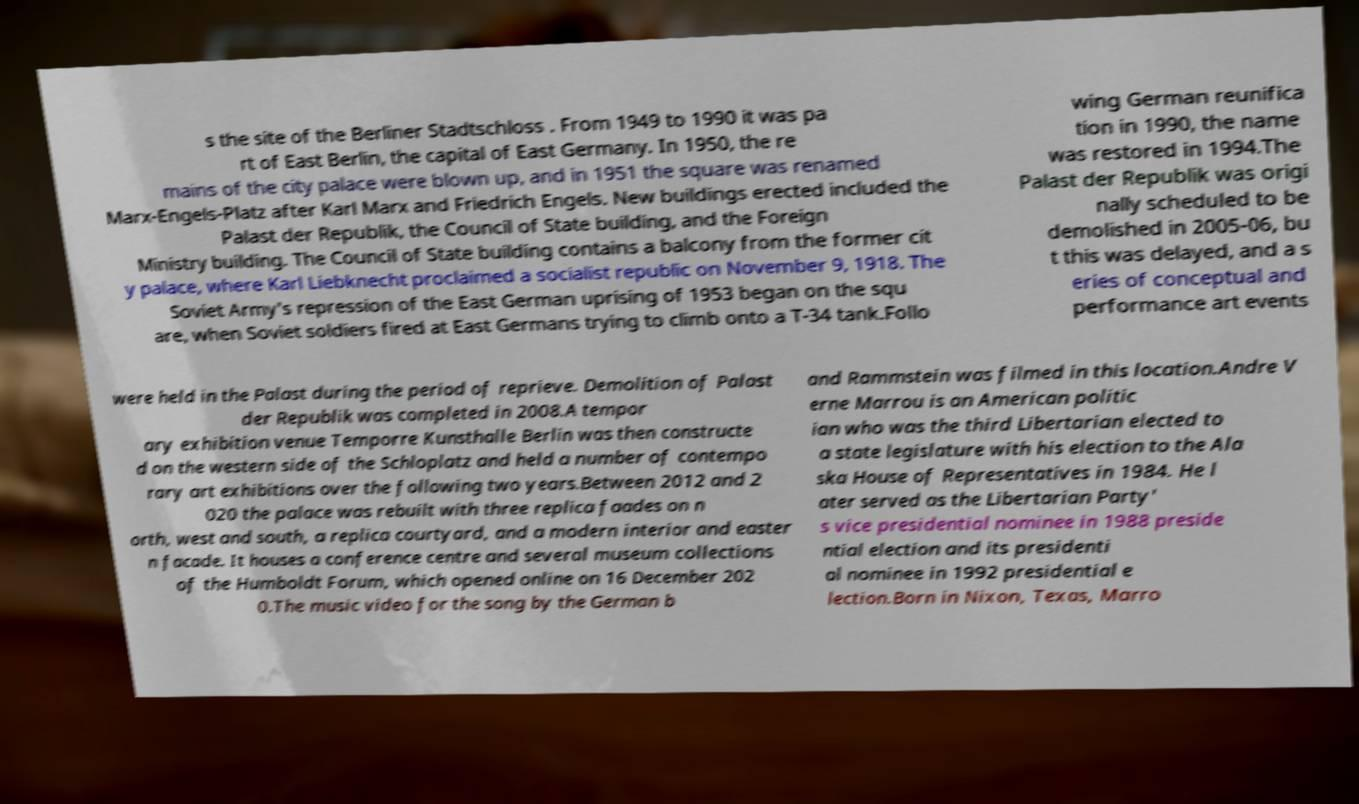What messages or text are displayed in this image? I need them in a readable, typed format. s the site of the Berliner Stadtschloss . From 1949 to 1990 it was pa rt of East Berlin, the capital of East Germany. In 1950, the re mains of the city palace were blown up, and in 1951 the square was renamed Marx-Engels-Platz after Karl Marx and Friedrich Engels. New buildings erected included the Palast der Republik, the Council of State building, and the Foreign Ministry building. The Council of State building contains a balcony from the former cit y palace, where Karl Liebknecht proclaimed a socialist republic on November 9, 1918. The Soviet Army's repression of the East German uprising of 1953 began on the squ are, when Soviet soldiers fired at East Germans trying to climb onto a T-34 tank.Follo wing German reunifica tion in 1990, the name was restored in 1994.The Palast der Republik was origi nally scheduled to be demolished in 2005-06, bu t this was delayed, and a s eries of conceptual and performance art events were held in the Palast during the period of reprieve. Demolition of Palast der Republik was completed in 2008.A tempor ary exhibition venue Temporre Kunsthalle Berlin was then constructe d on the western side of the Schloplatz and held a number of contempo rary art exhibitions over the following two years.Between 2012 and 2 020 the palace was rebuilt with three replica faades on n orth, west and south, a replica courtyard, and a modern interior and easter n facade. It houses a conference centre and several museum collections of the Humboldt Forum, which opened online on 16 December 202 0.The music video for the song by the German b and Rammstein was filmed in this location.Andre V erne Marrou is an American politic ian who was the third Libertarian elected to a state legislature with his election to the Ala ska House of Representatives in 1984. He l ater served as the Libertarian Party' s vice presidential nominee in 1988 preside ntial election and its presidenti al nominee in 1992 presidential e lection.Born in Nixon, Texas, Marro 